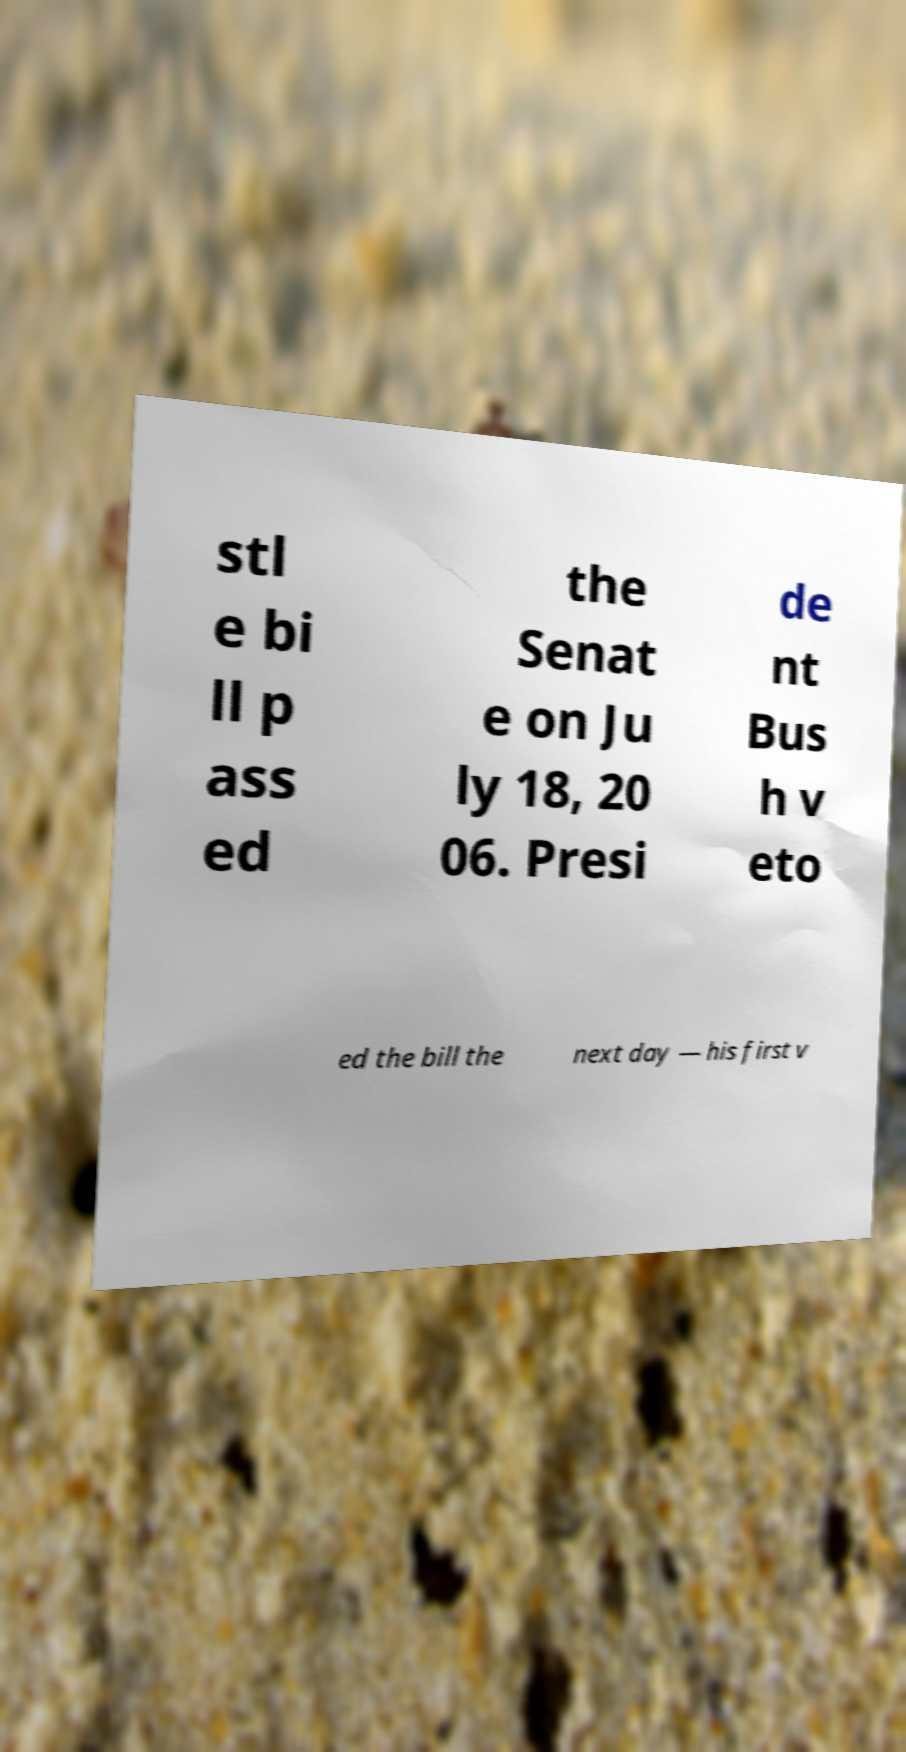For documentation purposes, I need the text within this image transcribed. Could you provide that? stl e bi ll p ass ed the Senat e on Ju ly 18, 20 06. Presi de nt Bus h v eto ed the bill the next day — his first v 